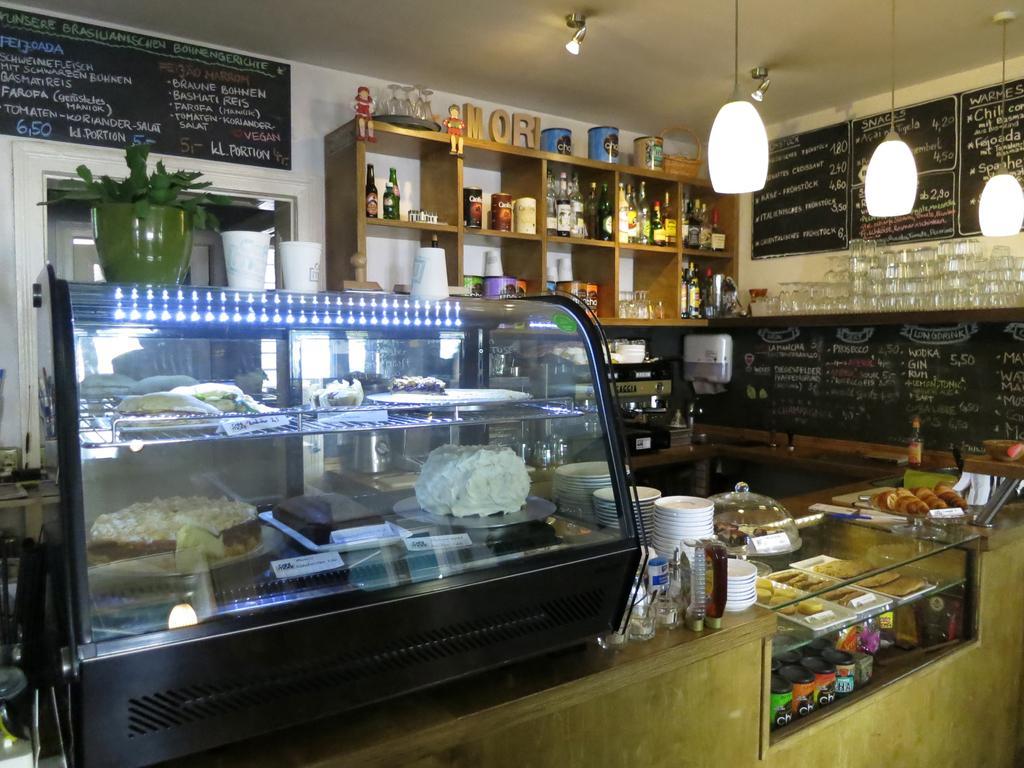Could you give a brief overview of what you see in this image? In this image I can see the stall. In the stall I can see the food in the glass rack. To the side I can see the plates, bottles, food and few more objects. I can see the flower pot. In the background I can see the glasses, bottles, tins and many objects in the wooden rack. I can see many boards attached to the wall. To the right I can see many glasses and there are lights at the top. 